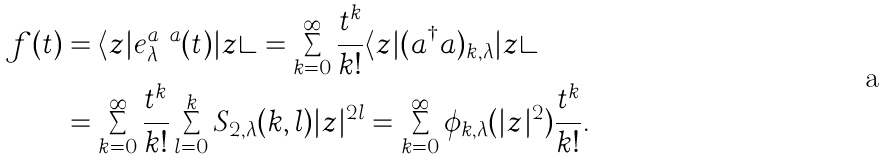Convert formula to latex. <formula><loc_0><loc_0><loc_500><loc_500>f ( t ) & = \langle z | e _ { \lambda } ^ { a ^ { \dagger } a } ( t ) | z \rangle = \sum _ { k = 0 } ^ { \infty } \frac { t ^ { k } } { k ! } \langle z | ( a ^ { \dagger } a ) _ { k , \lambda } | z \rangle \\ & = \sum _ { k = 0 } ^ { \infty } \frac { t ^ { k } } { k ! } \sum _ { l = 0 } ^ { k } S _ { 2 , \lambda } ( k , l ) | z | ^ { 2 l } = \sum _ { k = 0 } ^ { \infty } \phi _ { k , \lambda } ( | z | ^ { 2 } ) \frac { t ^ { k } } { k ! } .</formula> 